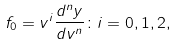<formula> <loc_0><loc_0><loc_500><loc_500>f _ { 0 } = v ^ { i } \frac { d ^ { n } y } { d v ^ { n } } \colon i = 0 , 1 , 2 ,</formula> 